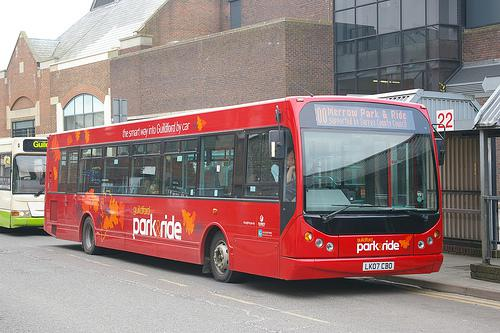Question: what number is this bus?
Choices:
A. 01.
B. 02.
C. 03.
D. 00.
Answer with the letter. Answer: D Question: how many buses are there?
Choices:
A. Four.
B. Two.
C. One.
D. Three.
Answer with the letter. Answer: B Question: what is this a photo of?
Choices:
A. A train.
B. A car.
C. An airplane.
D. A bus.
Answer with the letter. Answer: D Question: who drives the bus?
Choices:
A. A man.
B. A woman.
C. A teacher.
D. The bus driver.
Answer with the letter. Answer: D 